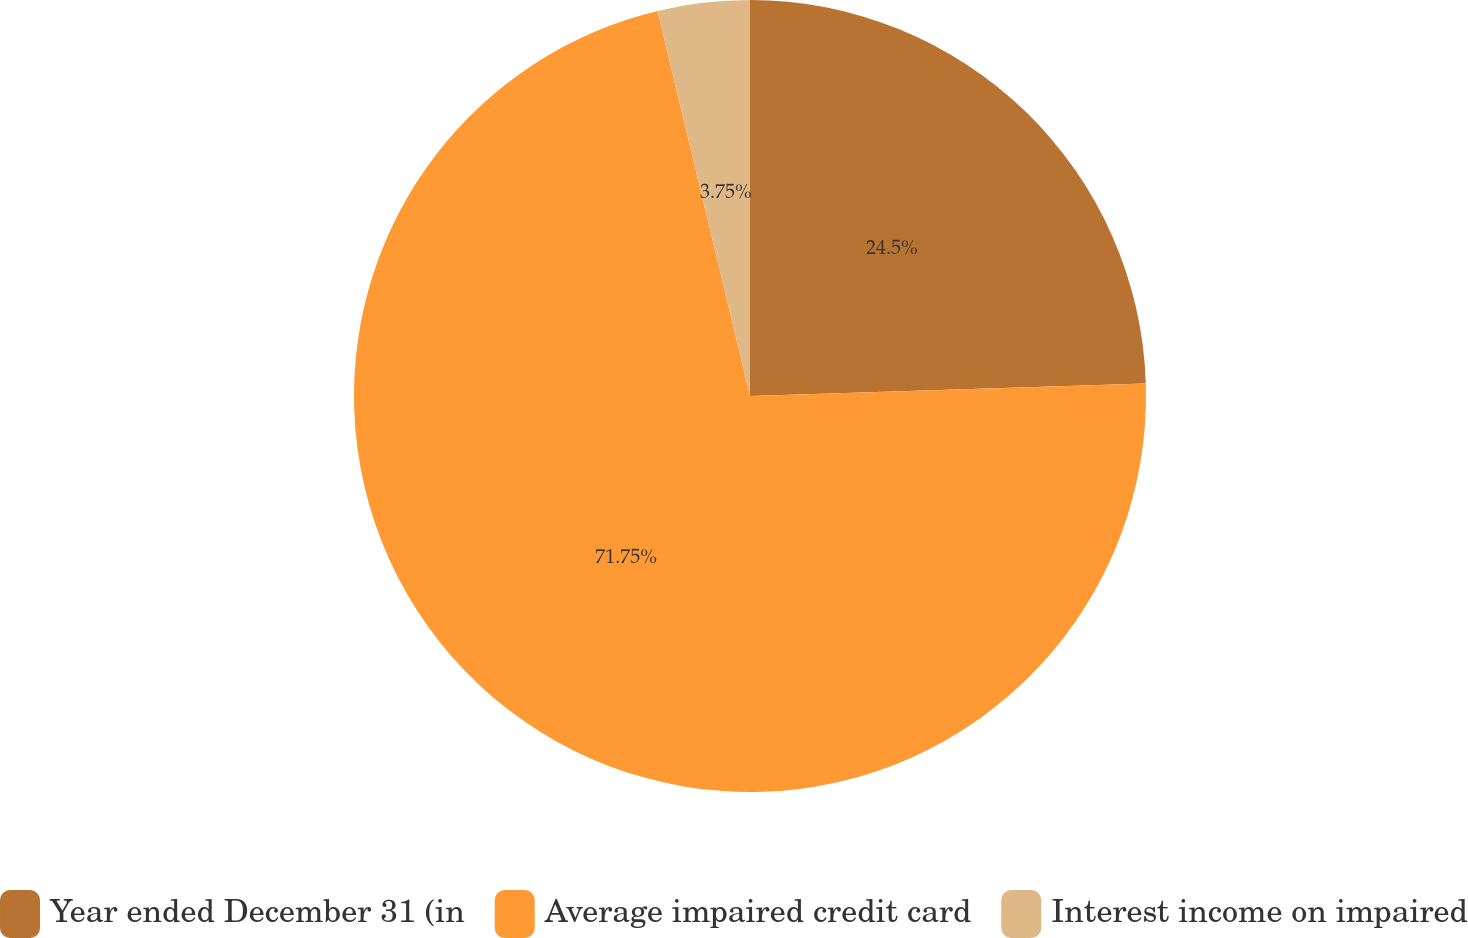Convert chart. <chart><loc_0><loc_0><loc_500><loc_500><pie_chart><fcel>Year ended December 31 (in<fcel>Average impaired credit card<fcel>Interest income on impaired<nl><fcel>24.5%<fcel>71.75%<fcel>3.75%<nl></chart> 